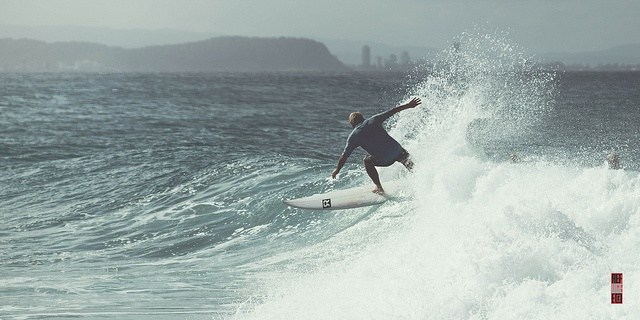Describe the objects in this image and their specific colors. I can see people in lightgray, gray, black, and darkgray tones and surfboard in lightgray, darkgray, and gray tones in this image. 